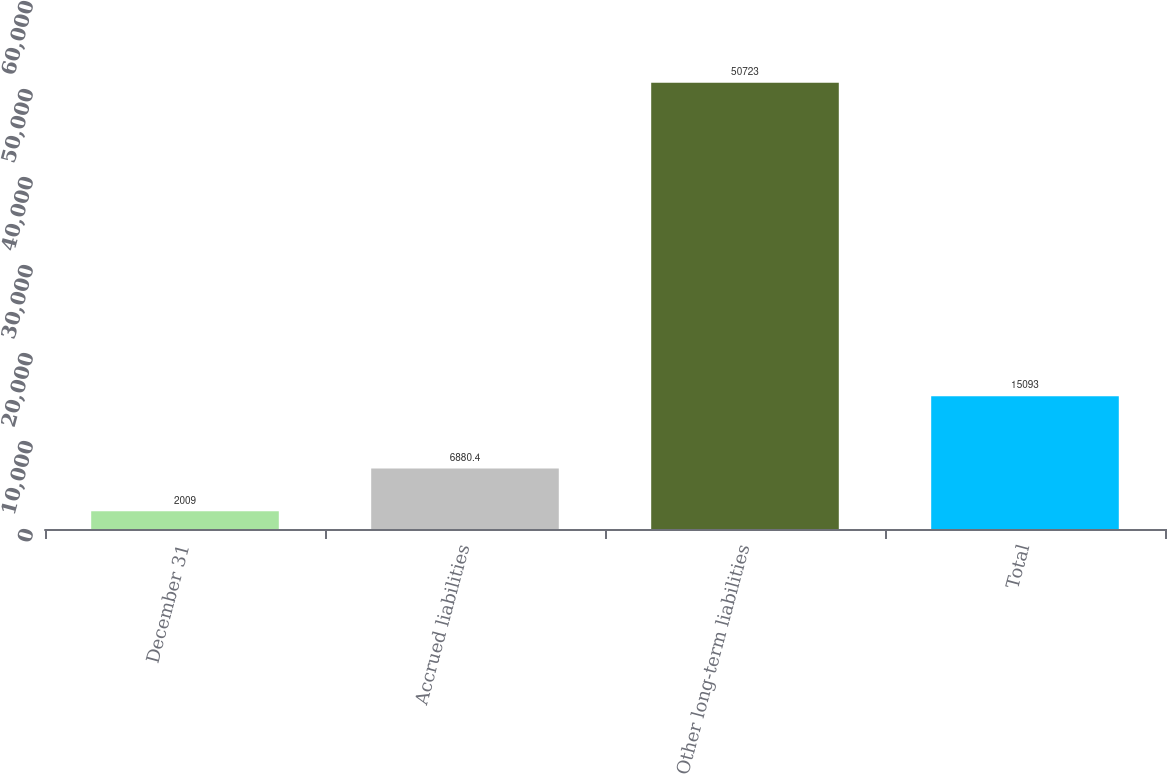Convert chart to OTSL. <chart><loc_0><loc_0><loc_500><loc_500><bar_chart><fcel>December 31<fcel>Accrued liabilities<fcel>Other long-term liabilities<fcel>Total<nl><fcel>2009<fcel>6880.4<fcel>50723<fcel>15093<nl></chart> 